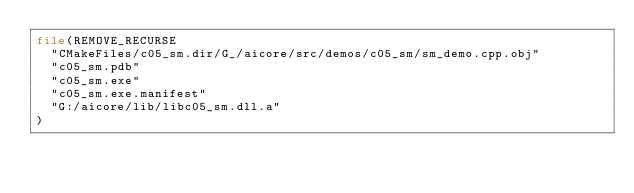<code> <loc_0><loc_0><loc_500><loc_500><_CMake_>file(REMOVE_RECURSE
  "CMakeFiles/c05_sm.dir/G_/aicore/src/demos/c05_sm/sm_demo.cpp.obj"
  "c05_sm.pdb"
  "c05_sm.exe"
  "c05_sm.exe.manifest"
  "G:/aicore/lib/libc05_sm.dll.a"
)
</code> 